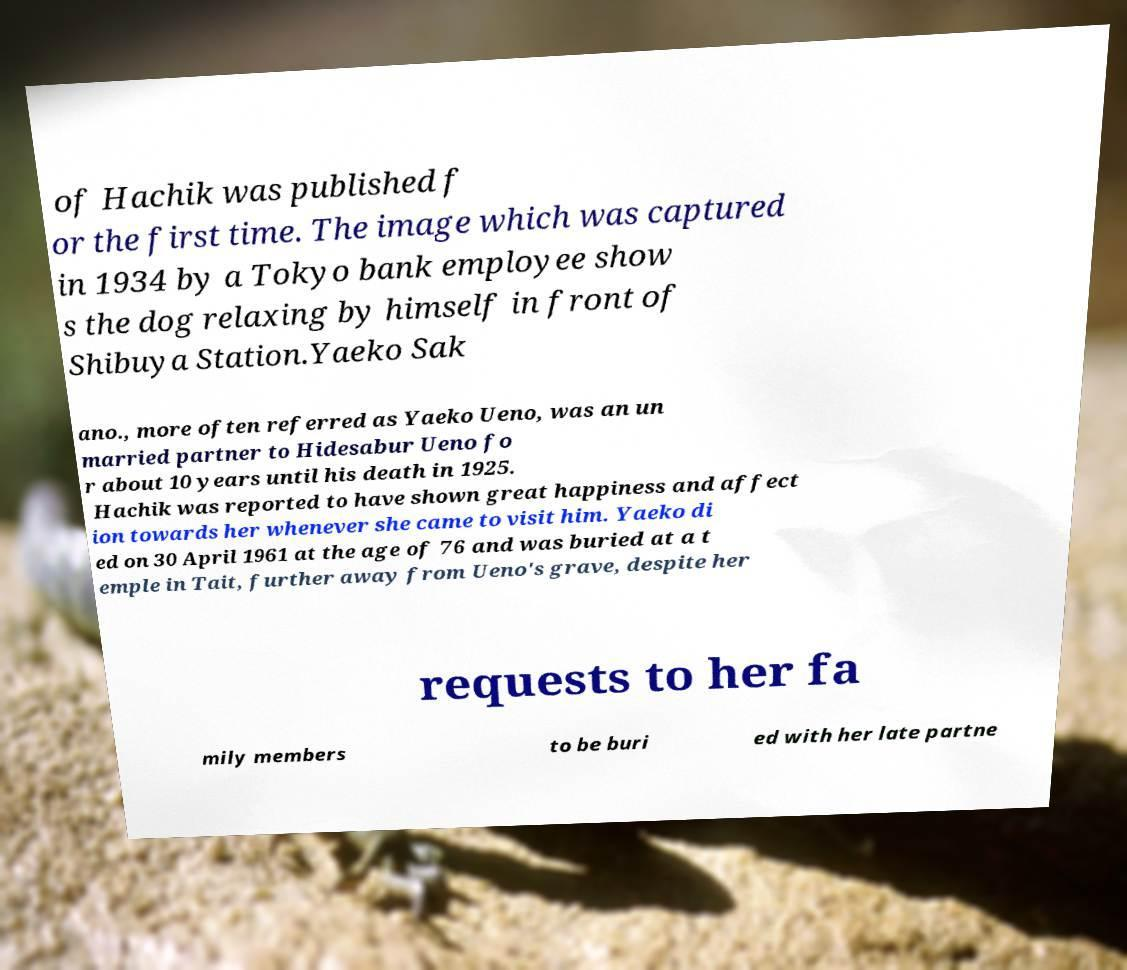I need the written content from this picture converted into text. Can you do that? of Hachik was published f or the first time. The image which was captured in 1934 by a Tokyo bank employee show s the dog relaxing by himself in front of Shibuya Station.Yaeko Sak ano., more often referred as Yaeko Ueno, was an un married partner to Hidesabur Ueno fo r about 10 years until his death in 1925. Hachik was reported to have shown great happiness and affect ion towards her whenever she came to visit him. Yaeko di ed on 30 April 1961 at the age of 76 and was buried at a t emple in Tait, further away from Ueno's grave, despite her requests to her fa mily members to be buri ed with her late partne 